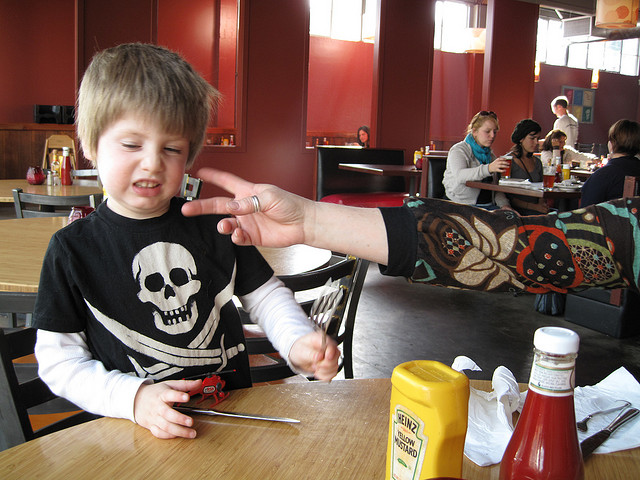Read all the text in this image. HEINZ YELLOW MUSTRAD 